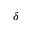Convert formula to latex. <formula><loc_0><loc_0><loc_500><loc_500>\delta</formula> 